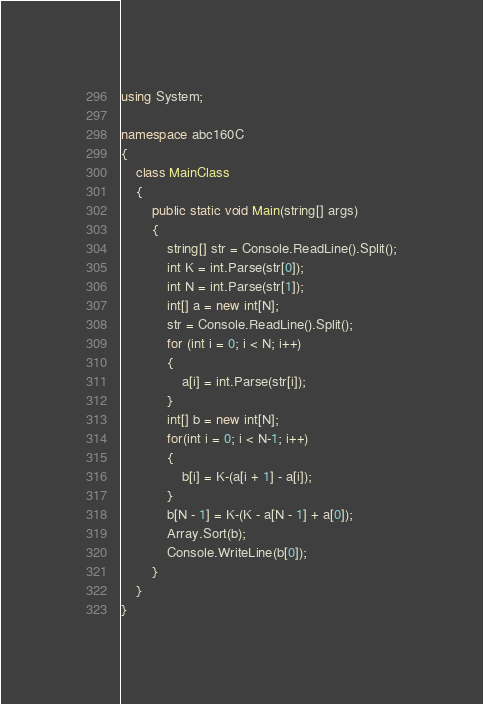<code> <loc_0><loc_0><loc_500><loc_500><_C#_>using System;

namespace abc160C
{
    class MainClass
    {
        public static void Main(string[] args)
        {
            string[] str = Console.ReadLine().Split();
            int K = int.Parse(str[0]);
            int N = int.Parse(str[1]);
            int[] a = new int[N];
            str = Console.ReadLine().Split();
            for (int i = 0; i < N; i++)
            {
                a[i] = int.Parse(str[i]);
            }
            int[] b = new int[N];
            for(int i = 0; i < N-1; i++)
            {
                b[i] = K-(a[i + 1] - a[i]);
            }
            b[N - 1] = K-(K - a[N - 1] + a[0]);
            Array.Sort(b);
            Console.WriteLine(b[0]);
        }
    }
}
</code> 